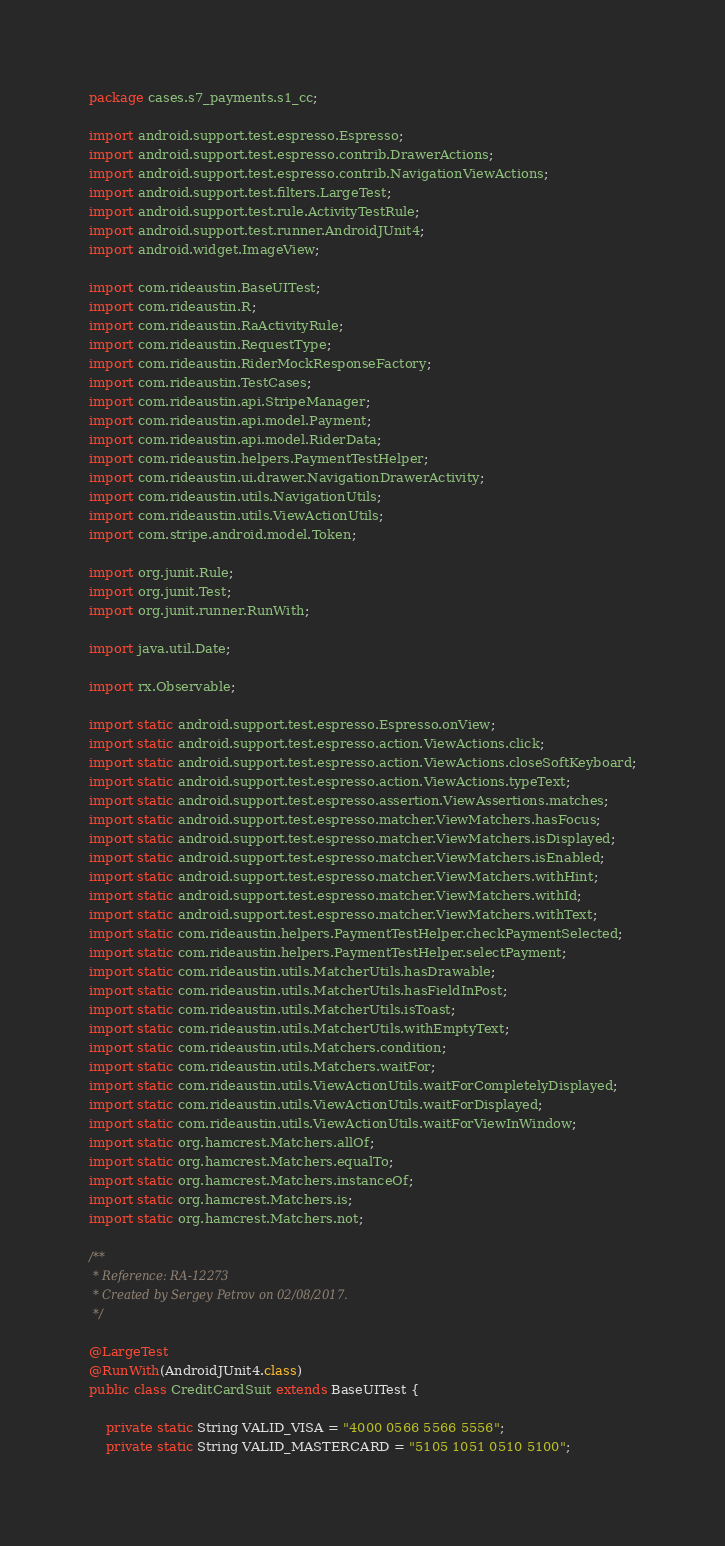<code> <loc_0><loc_0><loc_500><loc_500><_Java_>package cases.s7_payments.s1_cc;

import android.support.test.espresso.Espresso;
import android.support.test.espresso.contrib.DrawerActions;
import android.support.test.espresso.contrib.NavigationViewActions;
import android.support.test.filters.LargeTest;
import android.support.test.rule.ActivityTestRule;
import android.support.test.runner.AndroidJUnit4;
import android.widget.ImageView;

import com.rideaustin.BaseUITest;
import com.rideaustin.R;
import com.rideaustin.RaActivityRule;
import com.rideaustin.RequestType;
import com.rideaustin.RiderMockResponseFactory;
import com.rideaustin.TestCases;
import com.rideaustin.api.StripeManager;
import com.rideaustin.api.model.Payment;
import com.rideaustin.api.model.RiderData;
import com.rideaustin.helpers.PaymentTestHelper;
import com.rideaustin.ui.drawer.NavigationDrawerActivity;
import com.rideaustin.utils.NavigationUtils;
import com.rideaustin.utils.ViewActionUtils;
import com.stripe.android.model.Token;

import org.junit.Rule;
import org.junit.Test;
import org.junit.runner.RunWith;

import java.util.Date;

import rx.Observable;

import static android.support.test.espresso.Espresso.onView;
import static android.support.test.espresso.action.ViewActions.click;
import static android.support.test.espresso.action.ViewActions.closeSoftKeyboard;
import static android.support.test.espresso.action.ViewActions.typeText;
import static android.support.test.espresso.assertion.ViewAssertions.matches;
import static android.support.test.espresso.matcher.ViewMatchers.hasFocus;
import static android.support.test.espresso.matcher.ViewMatchers.isDisplayed;
import static android.support.test.espresso.matcher.ViewMatchers.isEnabled;
import static android.support.test.espresso.matcher.ViewMatchers.withHint;
import static android.support.test.espresso.matcher.ViewMatchers.withId;
import static android.support.test.espresso.matcher.ViewMatchers.withText;
import static com.rideaustin.helpers.PaymentTestHelper.checkPaymentSelected;
import static com.rideaustin.helpers.PaymentTestHelper.selectPayment;
import static com.rideaustin.utils.MatcherUtils.hasDrawable;
import static com.rideaustin.utils.MatcherUtils.hasFieldInPost;
import static com.rideaustin.utils.MatcherUtils.isToast;
import static com.rideaustin.utils.MatcherUtils.withEmptyText;
import static com.rideaustin.utils.Matchers.condition;
import static com.rideaustin.utils.Matchers.waitFor;
import static com.rideaustin.utils.ViewActionUtils.waitForCompletelyDisplayed;
import static com.rideaustin.utils.ViewActionUtils.waitForDisplayed;
import static com.rideaustin.utils.ViewActionUtils.waitForViewInWindow;
import static org.hamcrest.Matchers.allOf;
import static org.hamcrest.Matchers.equalTo;
import static org.hamcrest.Matchers.instanceOf;
import static org.hamcrest.Matchers.is;
import static org.hamcrest.Matchers.not;

/**
 * Reference: RA-12273
 * Created by Sergey Petrov on 02/08/2017.
 */

@LargeTest
@RunWith(AndroidJUnit4.class)
public class CreditCardSuit extends BaseUITest {

    private static String VALID_VISA = "4000 0566 5566 5556";
    private static String VALID_MASTERCARD = "5105 1051 0510 5100";</code> 